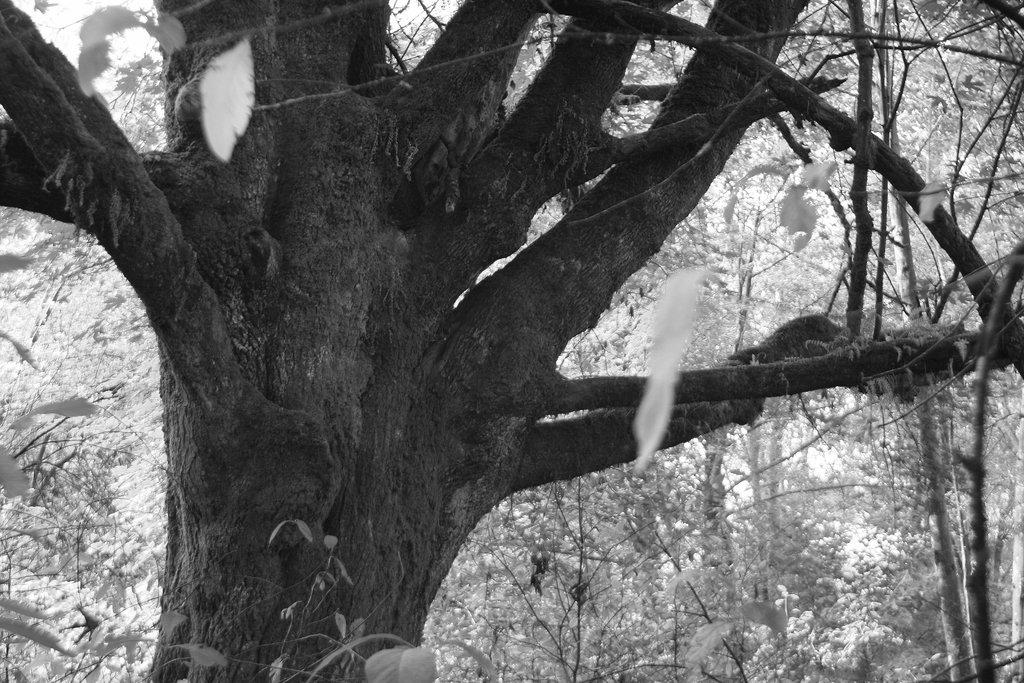What is the color scheme of the image? The image is black and white. What is the main subject in the center of the image? There is a tree trunk in the center of the image. What can be seen in the background of the image? There are trees in the background of the image. Is there a tray on the desk in the image? There is no desk or tray present in the image; it features a tree trunk and trees in the background. How much snow can be seen on the ground in the image? There is no snow visible in the image; it is a black and white image with a tree trunk and trees in the background. 